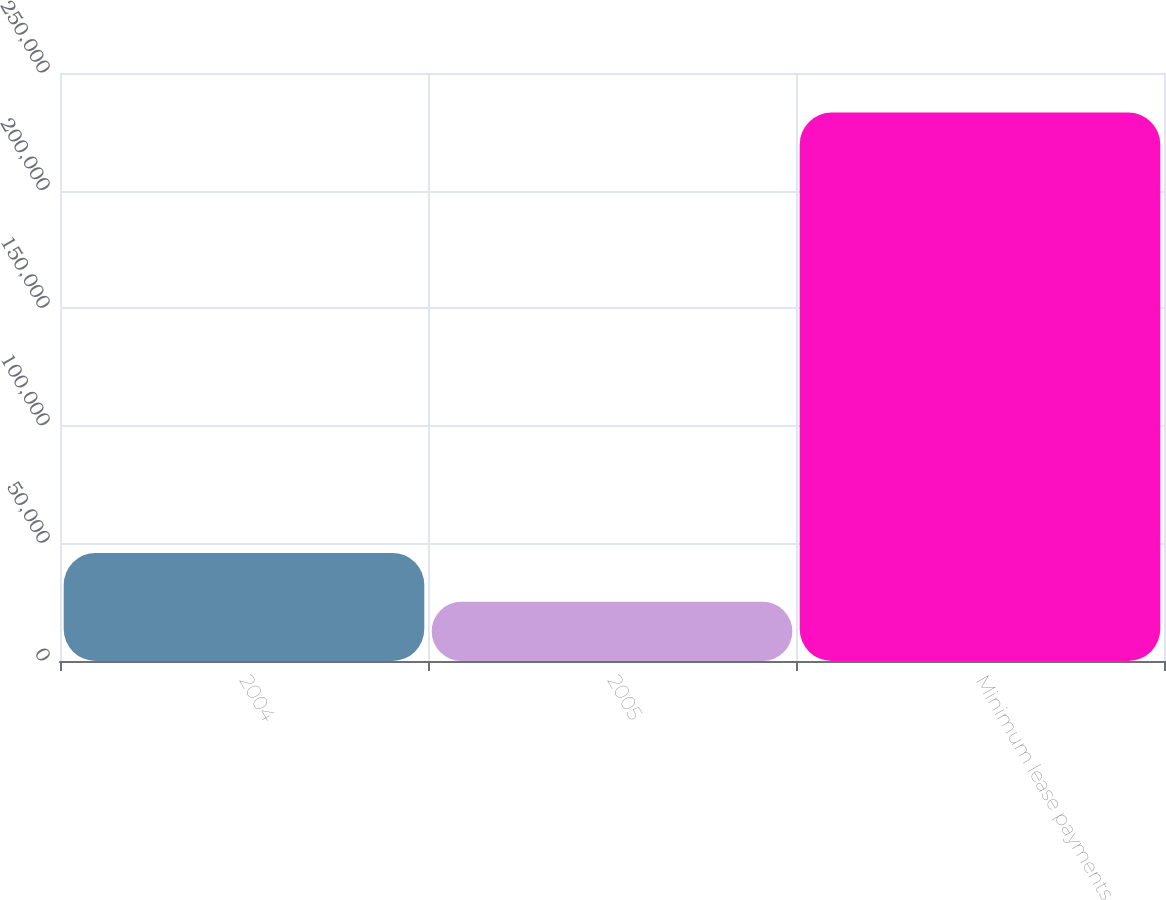Convert chart to OTSL. <chart><loc_0><loc_0><loc_500><loc_500><bar_chart><fcel>2004<fcel>2005<fcel>Minimum lease payments<nl><fcel>45958.8<fcel>25158<fcel>233166<nl></chart> 